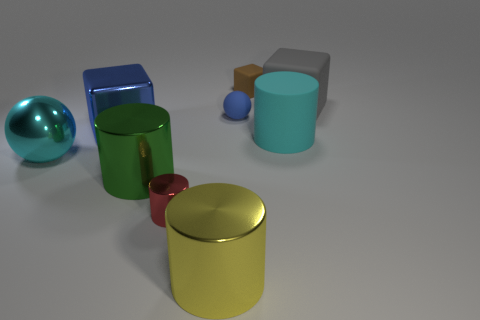What number of tiny cyan metal spheres are there?
Keep it short and to the point. 0. Are the cyan sphere and the tiny blue object made of the same material?
Ensure brevity in your answer.  No. What shape is the tiny object that is in front of the big rubber object on the left side of the big matte object behind the large rubber cylinder?
Provide a short and direct response. Cylinder. Are the small object left of the yellow cylinder and the big cube right of the brown matte thing made of the same material?
Provide a short and direct response. No. What material is the large blue thing?
Make the answer very short. Metal. How many other large objects have the same shape as the large yellow thing?
Make the answer very short. 2. There is a large cylinder that is the same color as the large metal ball; what material is it?
Make the answer very short. Rubber. The matte thing behind the matte block that is right of the small matte object on the right side of the tiny blue object is what color?
Provide a short and direct response. Brown. How many tiny objects are either blue things or red metallic things?
Give a very brief answer. 2. Is the number of spheres that are right of the large cyan metal object the same as the number of large shiny cylinders?
Offer a terse response. No. 